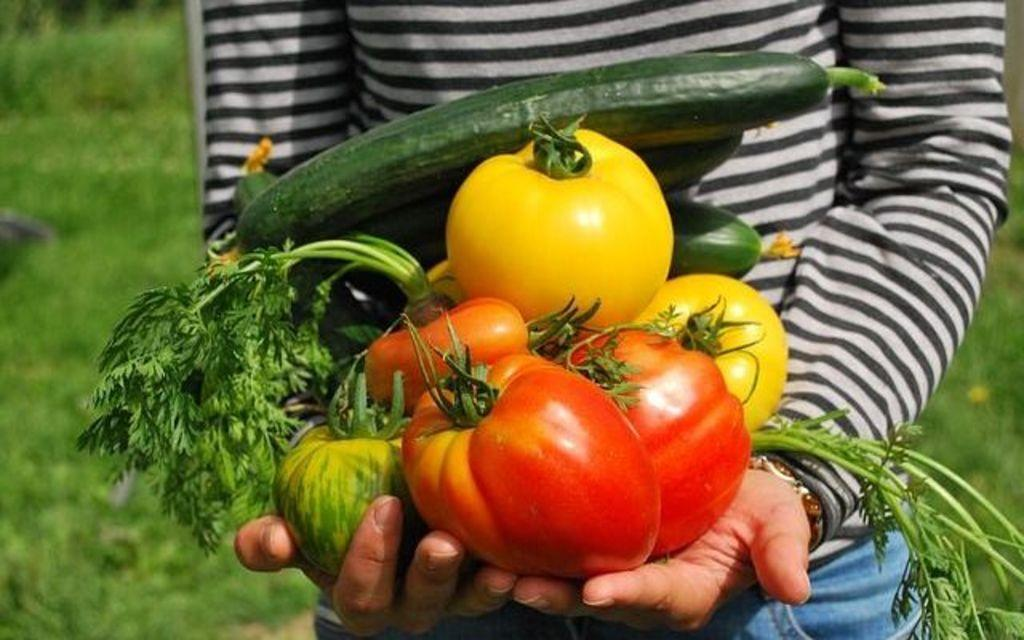What is the person in the image standing on? The person is standing on the grass surface in the image. What is the person holding in their hands? The person is holding vegetables in their hands. What type of clothing is the person wearing on their upper body? The person is wearing a full T-shirt. What color is the T-shirt? The T-shirt is blue in color. What color are the person's trousers? The person is wearing blue color trousers. How many centimeters is the person's elbow from the ground in the image? There is no information provided about the person's elbow or its distance from the ground in the image. 